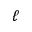Convert formula to latex. <formula><loc_0><loc_0><loc_500><loc_500>\ell</formula> 